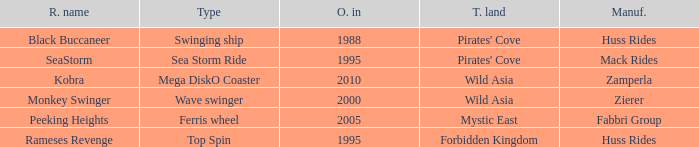What type ride is Wild Asia that opened in 2000? Wave swinger. 